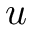<formula> <loc_0><loc_0><loc_500><loc_500>u</formula> 